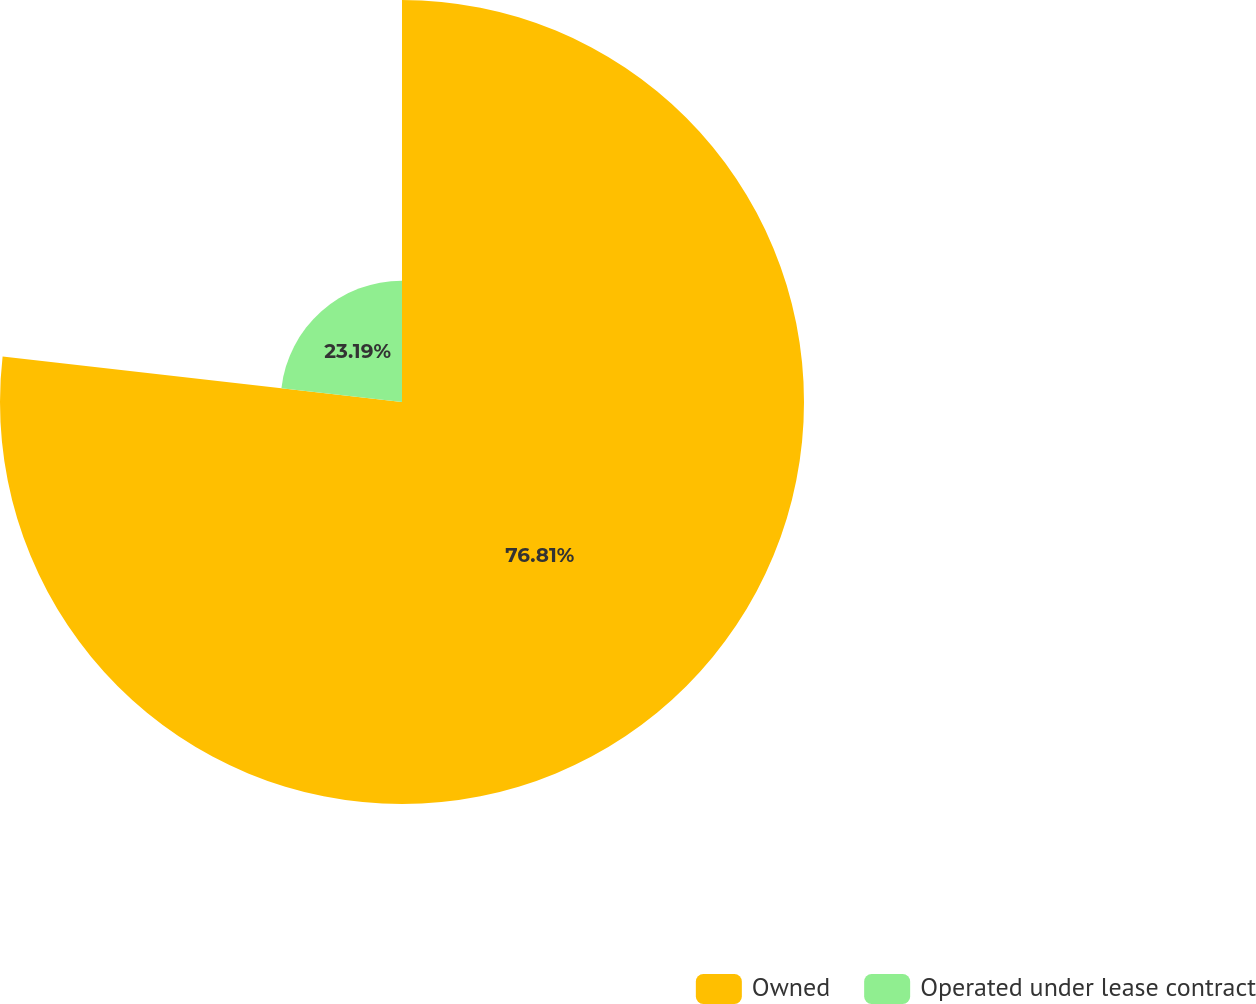Convert chart. <chart><loc_0><loc_0><loc_500><loc_500><pie_chart><fcel>Owned<fcel>Operated under lease contract<nl><fcel>76.81%<fcel>23.19%<nl></chart> 